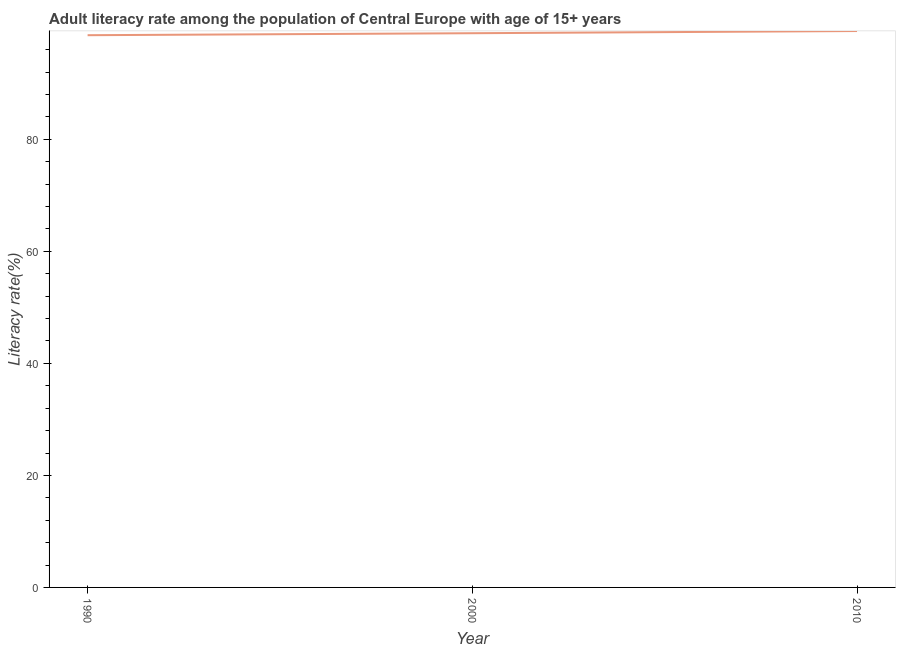What is the adult literacy rate in 1990?
Your response must be concise. 98.6. Across all years, what is the maximum adult literacy rate?
Provide a short and direct response. 99.34. Across all years, what is the minimum adult literacy rate?
Keep it short and to the point. 98.6. In which year was the adult literacy rate maximum?
Ensure brevity in your answer.  2010. In which year was the adult literacy rate minimum?
Your answer should be compact. 1990. What is the sum of the adult literacy rate?
Offer a very short reply. 296.89. What is the difference between the adult literacy rate in 1990 and 2000?
Provide a succinct answer. -0.35. What is the average adult literacy rate per year?
Offer a very short reply. 98.96. What is the median adult literacy rate?
Give a very brief answer. 98.95. In how many years, is the adult literacy rate greater than 88 %?
Offer a terse response. 3. Do a majority of the years between 2010 and 2000 (inclusive) have adult literacy rate greater than 52 %?
Offer a very short reply. No. What is the ratio of the adult literacy rate in 1990 to that in 2000?
Your response must be concise. 1. Is the difference between the adult literacy rate in 1990 and 2010 greater than the difference between any two years?
Offer a very short reply. Yes. What is the difference between the highest and the second highest adult literacy rate?
Offer a terse response. 0.39. Is the sum of the adult literacy rate in 1990 and 2000 greater than the maximum adult literacy rate across all years?
Give a very brief answer. Yes. What is the difference between the highest and the lowest adult literacy rate?
Your answer should be compact. 0.74. How many lines are there?
Keep it short and to the point. 1. How many years are there in the graph?
Offer a very short reply. 3. Are the values on the major ticks of Y-axis written in scientific E-notation?
Your response must be concise. No. What is the title of the graph?
Your response must be concise. Adult literacy rate among the population of Central Europe with age of 15+ years. What is the label or title of the Y-axis?
Keep it short and to the point. Literacy rate(%). What is the Literacy rate(%) in 1990?
Ensure brevity in your answer.  98.6. What is the Literacy rate(%) in 2000?
Give a very brief answer. 98.95. What is the Literacy rate(%) in 2010?
Your response must be concise. 99.34. What is the difference between the Literacy rate(%) in 1990 and 2000?
Your answer should be compact. -0.35. What is the difference between the Literacy rate(%) in 1990 and 2010?
Offer a terse response. -0.74. What is the difference between the Literacy rate(%) in 2000 and 2010?
Your response must be concise. -0.39. 